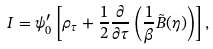<formula> <loc_0><loc_0><loc_500><loc_500>I = \psi _ { 0 } ^ { \prime } \left [ \rho _ { \tau } + \frac { 1 } { 2 } \frac { \partial } { \partial \tau } \left ( \frac { 1 } { \beta } \tilde { B } ( \eta ) \right ) \right ] ,</formula> 